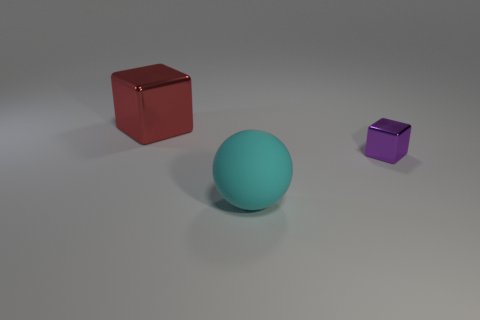Add 1 tiny green spheres. How many objects exist? 4 Subtract all blocks. How many objects are left? 1 Add 3 large purple shiny blocks. How many large purple shiny blocks exist? 3 Subtract 0 brown blocks. How many objects are left? 3 Subtract all big cyan matte cylinders. Subtract all small metallic blocks. How many objects are left? 2 Add 3 things. How many things are left? 6 